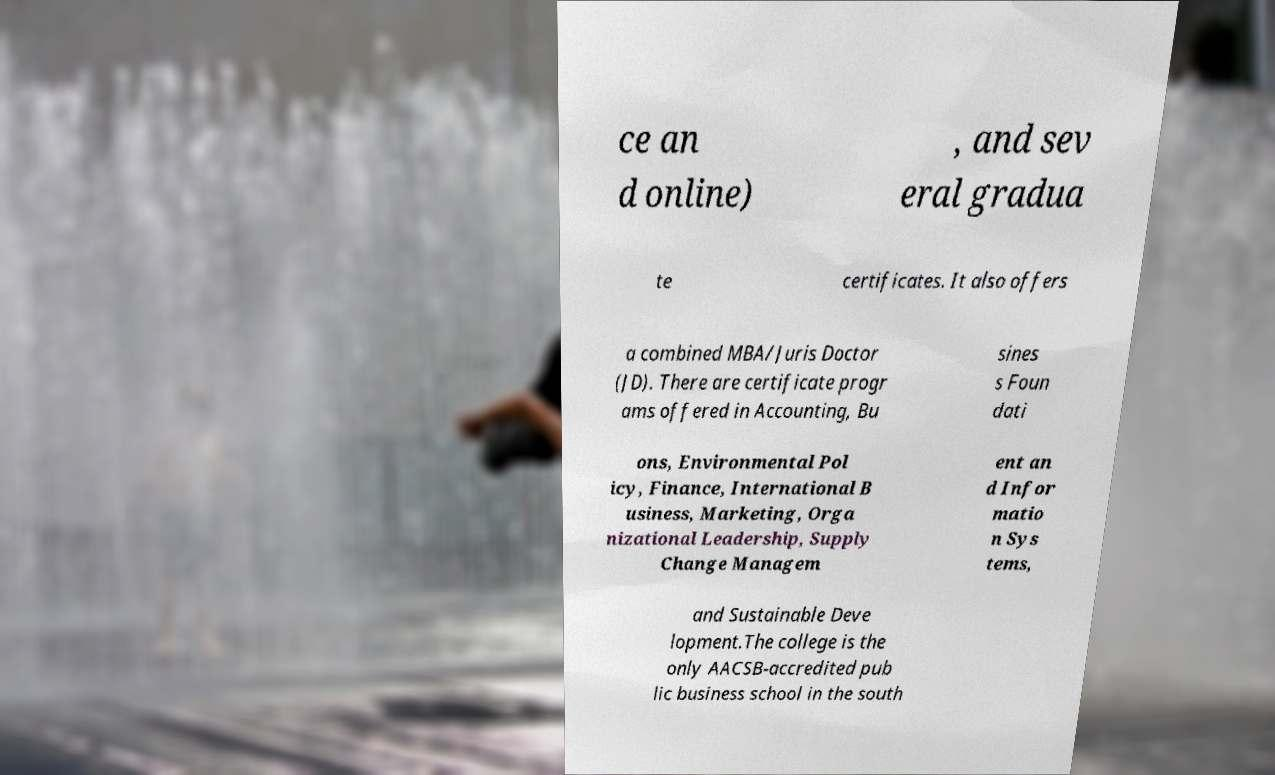I need the written content from this picture converted into text. Can you do that? ce an d online) , and sev eral gradua te certificates. It also offers a combined MBA/Juris Doctor (JD). There are certificate progr ams offered in Accounting, Bu sines s Foun dati ons, Environmental Pol icy, Finance, International B usiness, Marketing, Orga nizational Leadership, Supply Change Managem ent an d Infor matio n Sys tems, and Sustainable Deve lopment.The college is the only AACSB-accredited pub lic business school in the south 